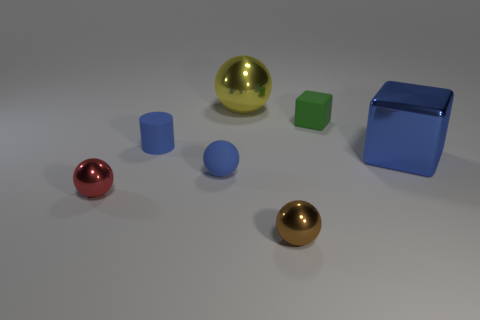What number of shiny cubes have the same size as the red sphere?
Keep it short and to the point. 0. What is the material of the small thing that is the same color as the tiny matte cylinder?
Offer a very short reply. Rubber. There is a metallic object right of the small brown metallic ball; is it the same shape as the red shiny object?
Provide a short and direct response. No. Is the number of small red shiny balls on the right side of the large blue shiny block less than the number of big yellow metallic objects?
Provide a short and direct response. Yes. Are there any other small balls that have the same color as the rubber sphere?
Provide a short and direct response. No. Is the shape of the blue shiny thing the same as the tiny rubber object right of the yellow ball?
Provide a short and direct response. Yes. Are there any yellow cylinders that have the same material as the brown sphere?
Keep it short and to the point. No. Are there any tiny blue rubber spheres that are in front of the tiny shiny ball that is in front of the small metal object that is to the left of the small brown sphere?
Offer a terse response. No. How many other things are there of the same shape as the green rubber object?
Ensure brevity in your answer.  1. What color is the metal sphere right of the big shiny object that is on the left side of the tiny matte object that is to the right of the yellow object?
Your response must be concise. Brown. 